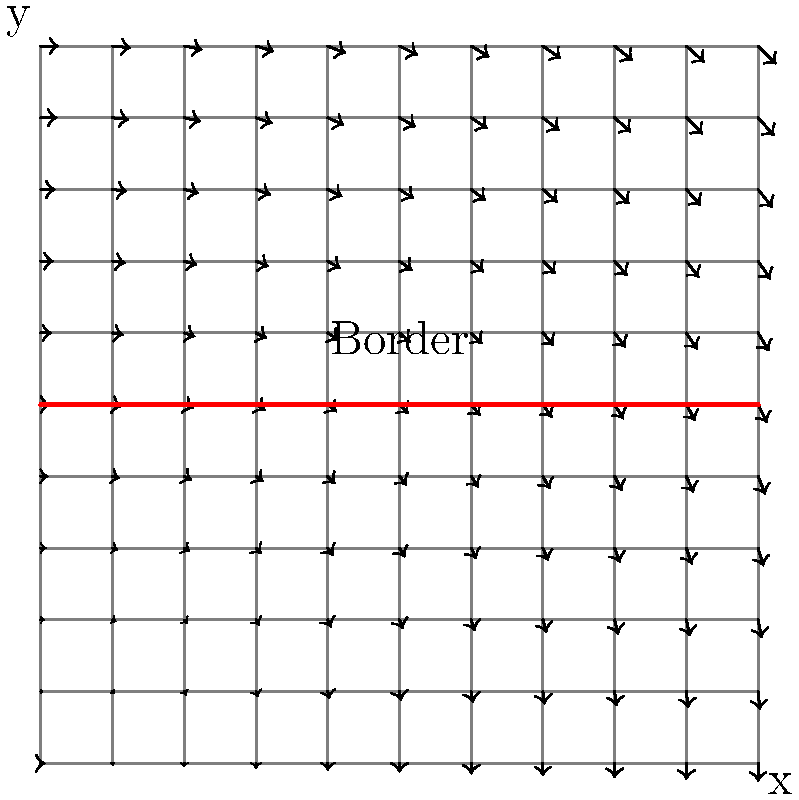Given the topographical map with a vector field representing the flow of illegal border crossings, calculate the flux across the border line from y=0 to y=0.5. The vector field is given by $\mathbf{F}(x,y) = (0.5y, -0.5x)$, and the border is represented by the line y=0.5 from x=0 to x=1. Use the line integral method to solve this problem. To solve this problem, we'll follow these steps:

1) The flux across a line is given by the line integral of the vector field dotted with the normal vector to the line.

2) The border line is y=0.5 from x=0 to x=1. The parameterization of this line is:
   $r(t) = (t, 0.5)$, where $0 \leq t \leq 1$

3) The normal vector to this line is $\mathbf{n} = (0, 1)$

4) We need to calculate:
   $\int_C \mathbf{F} \cdot \mathbf{n} \, ds$

5) Substituting our vector field and normal vector:
   $\int_0^1 (0.5y, -0.5x) \cdot (0, 1) \, dt$

6) Simplifying the dot product:
   $\int_0^1 -0.5x \, dt$

7) Along our line, y=0.5 is constant, but x varies with t. So x=t:
   $\int_0^1 -0.5t \, dt$

8) Integrate:
   $[-0.25t^2]_0^1$

9) Evaluate the integral:
   $(-0.25(1)^2) - (-0.25(0)^2) = -0.25$

The negative result indicates that the flow is crossing the border from north to south.
Answer: -0.25 